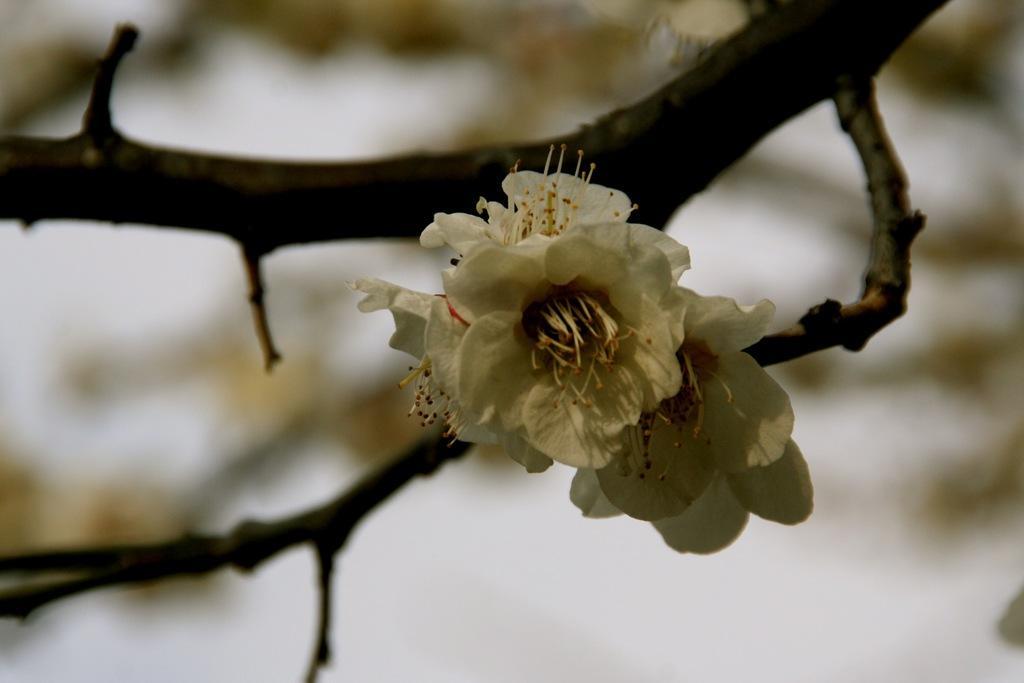Describe this image in one or two sentences. In the picture I can see flowers to the stem. 